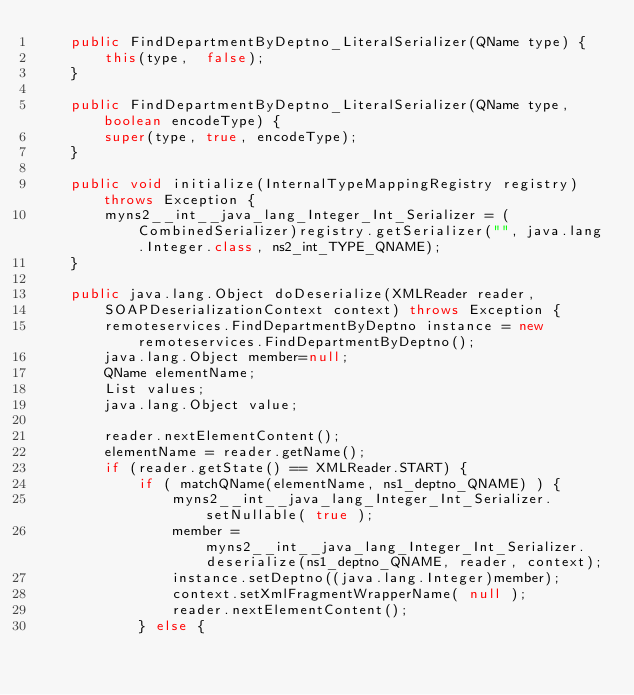Convert code to text. <code><loc_0><loc_0><loc_500><loc_500><_Java_>    public FindDepartmentByDeptno_LiteralSerializer(QName type) {
        this(type,  false);
    }
    
    public FindDepartmentByDeptno_LiteralSerializer(QName type, boolean encodeType) {
        super(type, true, encodeType);
    }
    
    public void initialize(InternalTypeMappingRegistry registry) throws Exception {
        myns2__int__java_lang_Integer_Int_Serializer = (CombinedSerializer)registry.getSerializer("", java.lang.Integer.class, ns2_int_TYPE_QNAME);
    }
    
    public java.lang.Object doDeserialize(XMLReader reader,
        SOAPDeserializationContext context) throws Exception {
        remoteservices.FindDepartmentByDeptno instance = new remoteservices.FindDepartmentByDeptno();
        java.lang.Object member=null;
        QName elementName;
        List values;
        java.lang.Object value;
        
        reader.nextElementContent();
        elementName = reader.getName();
        if (reader.getState() == XMLReader.START) {
            if ( matchQName(elementName, ns1_deptno_QNAME) ) {
                myns2__int__java_lang_Integer_Int_Serializer.setNullable( true );
                member = myns2__int__java_lang_Integer_Int_Serializer.deserialize(ns1_deptno_QNAME, reader, context);
                instance.setDeptno((java.lang.Integer)member);
                context.setXmlFragmentWrapperName( null );
                reader.nextElementContent();
            } else {</code> 